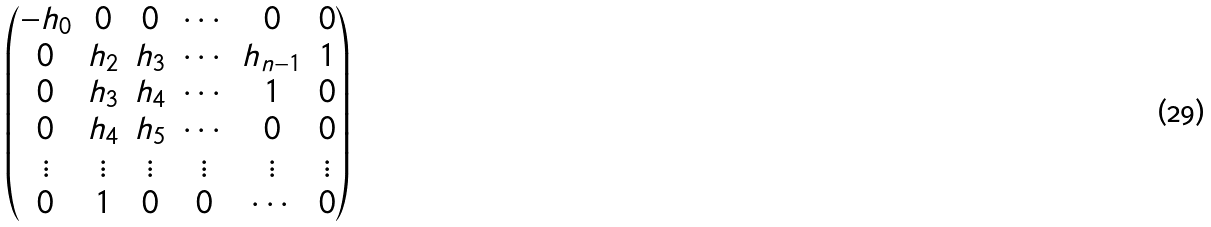<formula> <loc_0><loc_0><loc_500><loc_500>\begin{pmatrix} - h _ { 0 } & 0 & 0 & \cdots & 0 & 0 \\ 0 & h _ { 2 } & h _ { 3 } & \cdots & h _ { n - 1 } & 1 \\ 0 & h _ { 3 } & h _ { 4 } & \cdots & 1 & 0 \\ 0 & h _ { 4 } & h _ { 5 } & \cdots & 0 & 0 \\ \vdots & \vdots & \vdots & \vdots & \vdots & \vdots \\ 0 & 1 & 0 & 0 & \cdots & 0 \end{pmatrix}</formula> 